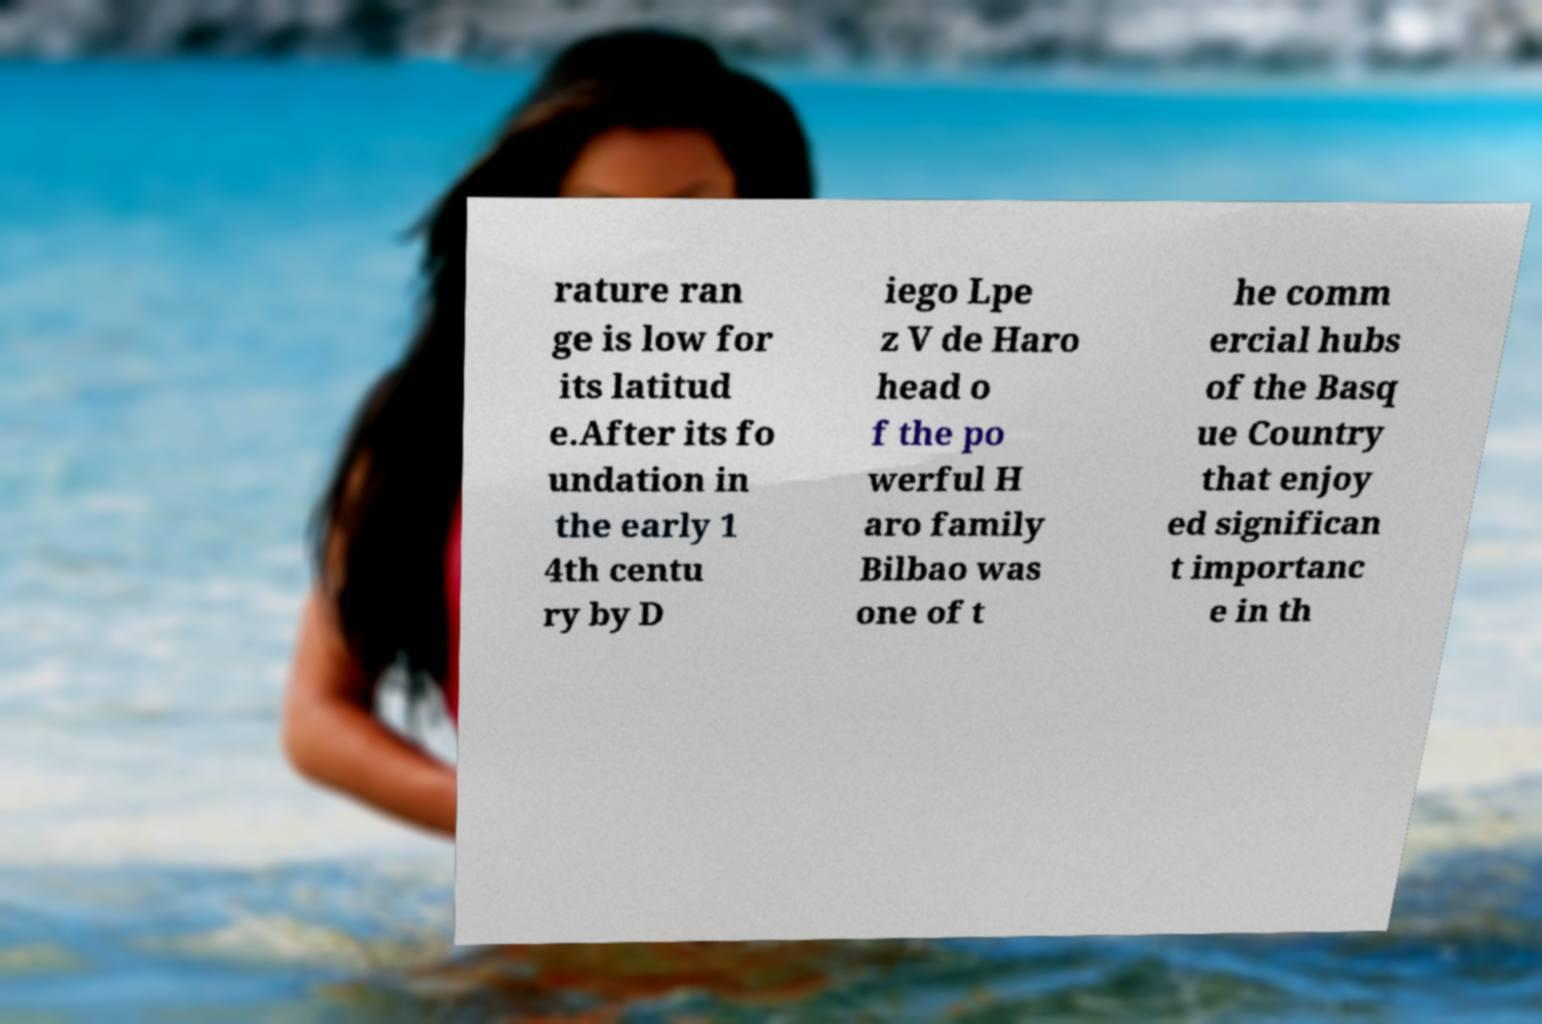I need the written content from this picture converted into text. Can you do that? rature ran ge is low for its latitud e.After its fo undation in the early 1 4th centu ry by D iego Lpe z V de Haro head o f the po werful H aro family Bilbao was one of t he comm ercial hubs of the Basq ue Country that enjoy ed significan t importanc e in th 